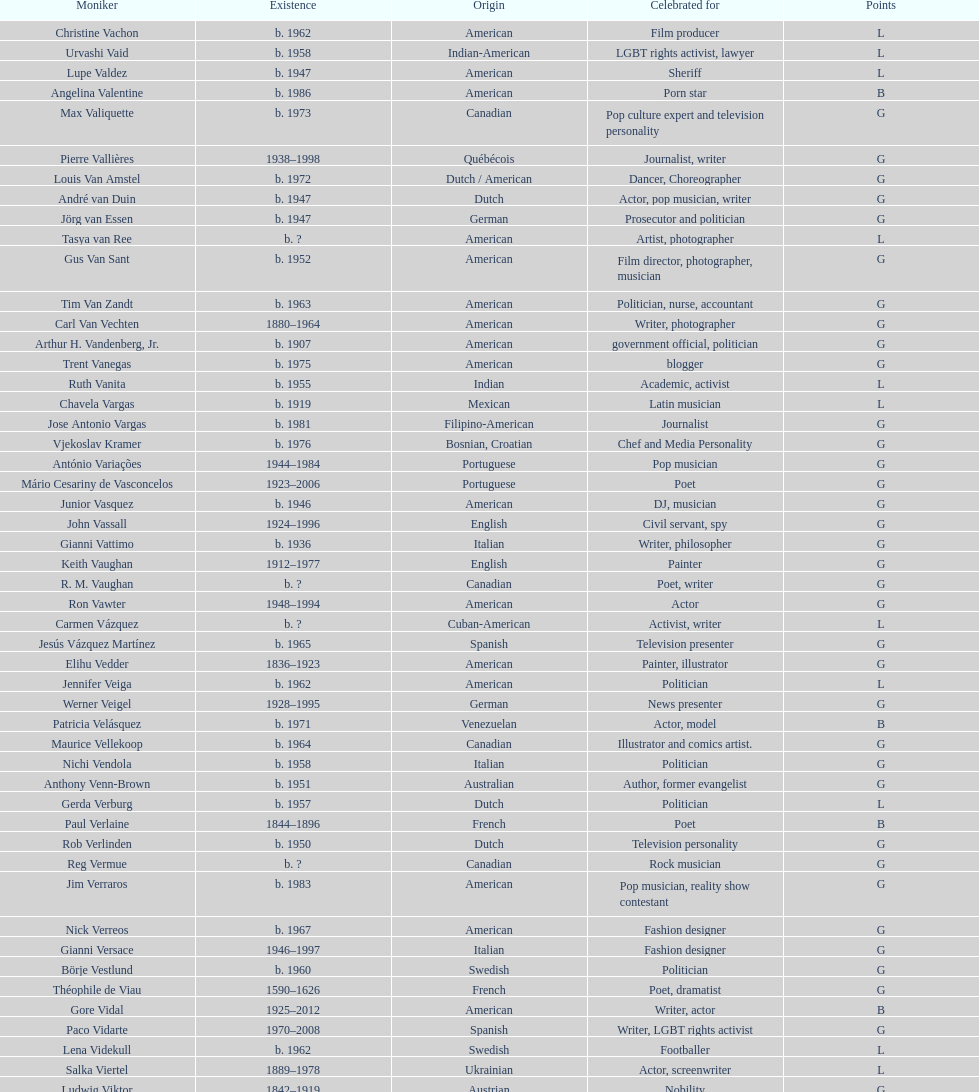How old was pierre vallieres before he died? 60. 